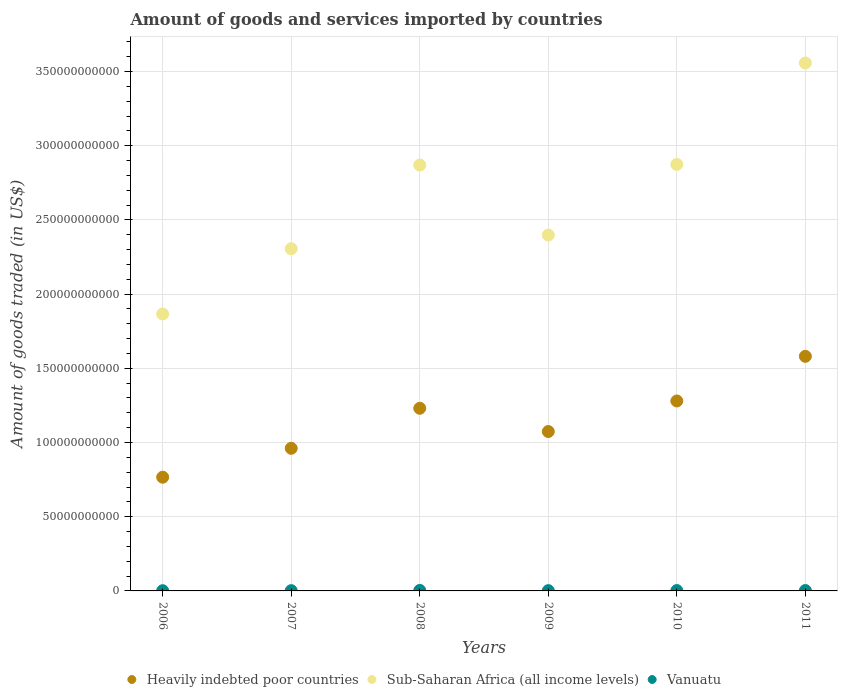Is the number of dotlines equal to the number of legend labels?
Offer a terse response. Yes. What is the total amount of goods and services imported in Heavily indebted poor countries in 2007?
Provide a short and direct response. 9.61e+1. Across all years, what is the maximum total amount of goods and services imported in Vanuatu?
Give a very brief answer. 3.18e+08. Across all years, what is the minimum total amount of goods and services imported in Vanuatu?
Your answer should be compact. 1.48e+08. In which year was the total amount of goods and services imported in Sub-Saharan Africa (all income levels) maximum?
Your answer should be compact. 2011. What is the total total amount of goods and services imported in Vanuatu in the graph?
Ensure brevity in your answer.  1.33e+09. What is the difference between the total amount of goods and services imported in Vanuatu in 2009 and that in 2011?
Give a very brief answer. -7.29e+07. What is the difference between the total amount of goods and services imported in Vanuatu in 2011 and the total amount of goods and services imported in Sub-Saharan Africa (all income levels) in 2008?
Provide a succinct answer. -2.87e+11. What is the average total amount of goods and services imported in Vanuatu per year?
Provide a short and direct response. 2.22e+08. In the year 2010, what is the difference between the total amount of goods and services imported in Vanuatu and total amount of goods and services imported in Sub-Saharan Africa (all income levels)?
Provide a short and direct response. -2.87e+11. What is the ratio of the total amount of goods and services imported in Heavily indebted poor countries in 2009 to that in 2010?
Keep it short and to the point. 0.84. What is the difference between the highest and the second highest total amount of goods and services imported in Sub-Saharan Africa (all income levels)?
Keep it short and to the point. 6.84e+1. What is the difference between the highest and the lowest total amount of goods and services imported in Vanuatu?
Provide a succinct answer. 1.70e+08. Is the sum of the total amount of goods and services imported in Vanuatu in 2006 and 2007 greater than the maximum total amount of goods and services imported in Sub-Saharan Africa (all income levels) across all years?
Offer a terse response. No. Is it the case that in every year, the sum of the total amount of goods and services imported in Vanuatu and total amount of goods and services imported in Heavily indebted poor countries  is greater than the total amount of goods and services imported in Sub-Saharan Africa (all income levels)?
Your answer should be very brief. No. How many dotlines are there?
Your response must be concise. 3. Does the graph contain grids?
Offer a very short reply. Yes. Where does the legend appear in the graph?
Provide a succinct answer. Bottom center. How many legend labels are there?
Give a very brief answer. 3. What is the title of the graph?
Give a very brief answer. Amount of goods and services imported by countries. What is the label or title of the Y-axis?
Keep it short and to the point. Amount of goods traded (in US$). What is the Amount of goods traded (in US$) of Heavily indebted poor countries in 2006?
Give a very brief answer. 7.66e+1. What is the Amount of goods traded (in US$) in Sub-Saharan Africa (all income levels) in 2006?
Your response must be concise. 1.87e+11. What is the Amount of goods traded (in US$) of Vanuatu in 2006?
Ensure brevity in your answer.  1.48e+08. What is the Amount of goods traded (in US$) of Heavily indebted poor countries in 2007?
Provide a short and direct response. 9.61e+1. What is the Amount of goods traded (in US$) of Sub-Saharan Africa (all income levels) in 2007?
Provide a succinct answer. 2.31e+11. What is the Amount of goods traded (in US$) of Vanuatu in 2007?
Your response must be concise. 1.76e+08. What is the Amount of goods traded (in US$) in Heavily indebted poor countries in 2008?
Offer a very short reply. 1.23e+11. What is the Amount of goods traded (in US$) in Sub-Saharan Africa (all income levels) in 2008?
Your answer should be very brief. 2.87e+11. What is the Amount of goods traded (in US$) in Vanuatu in 2008?
Ensure brevity in your answer.  3.18e+08. What is the Amount of goods traded (in US$) of Heavily indebted poor countries in 2009?
Ensure brevity in your answer.  1.07e+11. What is the Amount of goods traded (in US$) in Sub-Saharan Africa (all income levels) in 2009?
Provide a succinct answer. 2.40e+11. What is the Amount of goods traded (in US$) in Vanuatu in 2009?
Provide a short and direct response. 1.87e+08. What is the Amount of goods traded (in US$) of Heavily indebted poor countries in 2010?
Your answer should be very brief. 1.28e+11. What is the Amount of goods traded (in US$) in Sub-Saharan Africa (all income levels) in 2010?
Keep it short and to the point. 2.87e+11. What is the Amount of goods traded (in US$) of Vanuatu in 2010?
Provide a short and direct response. 2.44e+08. What is the Amount of goods traded (in US$) in Heavily indebted poor countries in 2011?
Give a very brief answer. 1.58e+11. What is the Amount of goods traded (in US$) of Sub-Saharan Africa (all income levels) in 2011?
Provide a succinct answer. 3.56e+11. What is the Amount of goods traded (in US$) in Vanuatu in 2011?
Keep it short and to the point. 2.60e+08. Across all years, what is the maximum Amount of goods traded (in US$) of Heavily indebted poor countries?
Make the answer very short. 1.58e+11. Across all years, what is the maximum Amount of goods traded (in US$) of Sub-Saharan Africa (all income levels)?
Make the answer very short. 3.56e+11. Across all years, what is the maximum Amount of goods traded (in US$) of Vanuatu?
Offer a very short reply. 3.18e+08. Across all years, what is the minimum Amount of goods traded (in US$) in Heavily indebted poor countries?
Your answer should be very brief. 7.66e+1. Across all years, what is the minimum Amount of goods traded (in US$) in Sub-Saharan Africa (all income levels)?
Provide a short and direct response. 1.87e+11. Across all years, what is the minimum Amount of goods traded (in US$) in Vanuatu?
Provide a short and direct response. 1.48e+08. What is the total Amount of goods traded (in US$) in Heavily indebted poor countries in the graph?
Your answer should be compact. 6.89e+11. What is the total Amount of goods traded (in US$) of Sub-Saharan Africa (all income levels) in the graph?
Your answer should be compact. 1.59e+12. What is the total Amount of goods traded (in US$) of Vanuatu in the graph?
Give a very brief answer. 1.33e+09. What is the difference between the Amount of goods traded (in US$) of Heavily indebted poor countries in 2006 and that in 2007?
Make the answer very short. -1.95e+1. What is the difference between the Amount of goods traded (in US$) of Sub-Saharan Africa (all income levels) in 2006 and that in 2007?
Offer a terse response. -4.40e+1. What is the difference between the Amount of goods traded (in US$) in Vanuatu in 2006 and that in 2007?
Provide a succinct answer. -2.89e+07. What is the difference between the Amount of goods traded (in US$) of Heavily indebted poor countries in 2006 and that in 2008?
Offer a terse response. -4.65e+1. What is the difference between the Amount of goods traded (in US$) of Sub-Saharan Africa (all income levels) in 2006 and that in 2008?
Make the answer very short. -1.00e+11. What is the difference between the Amount of goods traded (in US$) of Vanuatu in 2006 and that in 2008?
Offer a very short reply. -1.70e+08. What is the difference between the Amount of goods traded (in US$) of Heavily indebted poor countries in 2006 and that in 2009?
Your answer should be very brief. -3.08e+1. What is the difference between the Amount of goods traded (in US$) of Sub-Saharan Africa (all income levels) in 2006 and that in 2009?
Ensure brevity in your answer.  -5.32e+1. What is the difference between the Amount of goods traded (in US$) in Vanuatu in 2006 and that in 2009?
Your answer should be compact. -3.96e+07. What is the difference between the Amount of goods traded (in US$) in Heavily indebted poor countries in 2006 and that in 2010?
Give a very brief answer. -5.14e+1. What is the difference between the Amount of goods traded (in US$) of Sub-Saharan Africa (all income levels) in 2006 and that in 2010?
Offer a terse response. -1.01e+11. What is the difference between the Amount of goods traded (in US$) of Vanuatu in 2006 and that in 2010?
Provide a short and direct response. -9.62e+07. What is the difference between the Amount of goods traded (in US$) of Heavily indebted poor countries in 2006 and that in 2011?
Give a very brief answer. -8.14e+1. What is the difference between the Amount of goods traded (in US$) in Sub-Saharan Africa (all income levels) in 2006 and that in 2011?
Your answer should be very brief. -1.69e+11. What is the difference between the Amount of goods traded (in US$) of Vanuatu in 2006 and that in 2011?
Offer a very short reply. -1.12e+08. What is the difference between the Amount of goods traded (in US$) of Heavily indebted poor countries in 2007 and that in 2008?
Your answer should be compact. -2.70e+1. What is the difference between the Amount of goods traded (in US$) of Sub-Saharan Africa (all income levels) in 2007 and that in 2008?
Keep it short and to the point. -5.64e+1. What is the difference between the Amount of goods traded (in US$) in Vanuatu in 2007 and that in 2008?
Give a very brief answer. -1.41e+08. What is the difference between the Amount of goods traded (in US$) in Heavily indebted poor countries in 2007 and that in 2009?
Make the answer very short. -1.13e+1. What is the difference between the Amount of goods traded (in US$) in Sub-Saharan Africa (all income levels) in 2007 and that in 2009?
Ensure brevity in your answer.  -9.21e+09. What is the difference between the Amount of goods traded (in US$) of Vanuatu in 2007 and that in 2009?
Offer a very short reply. -1.07e+07. What is the difference between the Amount of goods traded (in US$) of Heavily indebted poor countries in 2007 and that in 2010?
Make the answer very short. -3.19e+1. What is the difference between the Amount of goods traded (in US$) of Sub-Saharan Africa (all income levels) in 2007 and that in 2010?
Your answer should be compact. -5.68e+1. What is the difference between the Amount of goods traded (in US$) in Vanuatu in 2007 and that in 2010?
Ensure brevity in your answer.  -6.73e+07. What is the difference between the Amount of goods traded (in US$) of Heavily indebted poor countries in 2007 and that in 2011?
Make the answer very short. -6.20e+1. What is the difference between the Amount of goods traded (in US$) in Sub-Saharan Africa (all income levels) in 2007 and that in 2011?
Provide a succinct answer. -1.25e+11. What is the difference between the Amount of goods traded (in US$) in Vanuatu in 2007 and that in 2011?
Provide a succinct answer. -8.36e+07. What is the difference between the Amount of goods traded (in US$) of Heavily indebted poor countries in 2008 and that in 2009?
Offer a terse response. 1.57e+1. What is the difference between the Amount of goods traded (in US$) in Sub-Saharan Africa (all income levels) in 2008 and that in 2009?
Give a very brief answer. 4.72e+1. What is the difference between the Amount of goods traded (in US$) of Vanuatu in 2008 and that in 2009?
Provide a succinct answer. 1.31e+08. What is the difference between the Amount of goods traded (in US$) of Heavily indebted poor countries in 2008 and that in 2010?
Your answer should be very brief. -4.91e+09. What is the difference between the Amount of goods traded (in US$) in Sub-Saharan Africa (all income levels) in 2008 and that in 2010?
Make the answer very short. -4.25e+08. What is the difference between the Amount of goods traded (in US$) in Vanuatu in 2008 and that in 2010?
Give a very brief answer. 7.40e+07. What is the difference between the Amount of goods traded (in US$) in Heavily indebted poor countries in 2008 and that in 2011?
Offer a terse response. -3.50e+1. What is the difference between the Amount of goods traded (in US$) in Sub-Saharan Africa (all income levels) in 2008 and that in 2011?
Your response must be concise. -6.88e+1. What is the difference between the Amount of goods traded (in US$) in Vanuatu in 2008 and that in 2011?
Your answer should be compact. 5.77e+07. What is the difference between the Amount of goods traded (in US$) in Heavily indebted poor countries in 2009 and that in 2010?
Your response must be concise. -2.06e+1. What is the difference between the Amount of goods traded (in US$) of Sub-Saharan Africa (all income levels) in 2009 and that in 2010?
Give a very brief answer. -4.76e+1. What is the difference between the Amount of goods traded (in US$) of Vanuatu in 2009 and that in 2010?
Your answer should be compact. -5.66e+07. What is the difference between the Amount of goods traded (in US$) in Heavily indebted poor countries in 2009 and that in 2011?
Your response must be concise. -5.07e+1. What is the difference between the Amount of goods traded (in US$) in Sub-Saharan Africa (all income levels) in 2009 and that in 2011?
Your response must be concise. -1.16e+11. What is the difference between the Amount of goods traded (in US$) of Vanuatu in 2009 and that in 2011?
Give a very brief answer. -7.29e+07. What is the difference between the Amount of goods traded (in US$) of Heavily indebted poor countries in 2010 and that in 2011?
Keep it short and to the point. -3.01e+1. What is the difference between the Amount of goods traded (in US$) in Sub-Saharan Africa (all income levels) in 2010 and that in 2011?
Provide a short and direct response. -6.84e+1. What is the difference between the Amount of goods traded (in US$) in Vanuatu in 2010 and that in 2011?
Offer a terse response. -1.62e+07. What is the difference between the Amount of goods traded (in US$) in Heavily indebted poor countries in 2006 and the Amount of goods traded (in US$) in Sub-Saharan Africa (all income levels) in 2007?
Keep it short and to the point. -1.54e+11. What is the difference between the Amount of goods traded (in US$) in Heavily indebted poor countries in 2006 and the Amount of goods traded (in US$) in Vanuatu in 2007?
Offer a terse response. 7.64e+1. What is the difference between the Amount of goods traded (in US$) in Sub-Saharan Africa (all income levels) in 2006 and the Amount of goods traded (in US$) in Vanuatu in 2007?
Your answer should be compact. 1.86e+11. What is the difference between the Amount of goods traded (in US$) in Heavily indebted poor countries in 2006 and the Amount of goods traded (in US$) in Sub-Saharan Africa (all income levels) in 2008?
Ensure brevity in your answer.  -2.10e+11. What is the difference between the Amount of goods traded (in US$) of Heavily indebted poor countries in 2006 and the Amount of goods traded (in US$) of Vanuatu in 2008?
Provide a succinct answer. 7.63e+1. What is the difference between the Amount of goods traded (in US$) in Sub-Saharan Africa (all income levels) in 2006 and the Amount of goods traded (in US$) in Vanuatu in 2008?
Your answer should be compact. 1.86e+11. What is the difference between the Amount of goods traded (in US$) of Heavily indebted poor countries in 2006 and the Amount of goods traded (in US$) of Sub-Saharan Africa (all income levels) in 2009?
Keep it short and to the point. -1.63e+11. What is the difference between the Amount of goods traded (in US$) in Heavily indebted poor countries in 2006 and the Amount of goods traded (in US$) in Vanuatu in 2009?
Your response must be concise. 7.64e+1. What is the difference between the Amount of goods traded (in US$) of Sub-Saharan Africa (all income levels) in 2006 and the Amount of goods traded (in US$) of Vanuatu in 2009?
Ensure brevity in your answer.  1.86e+11. What is the difference between the Amount of goods traded (in US$) in Heavily indebted poor countries in 2006 and the Amount of goods traded (in US$) in Sub-Saharan Africa (all income levels) in 2010?
Your answer should be compact. -2.11e+11. What is the difference between the Amount of goods traded (in US$) of Heavily indebted poor countries in 2006 and the Amount of goods traded (in US$) of Vanuatu in 2010?
Provide a short and direct response. 7.64e+1. What is the difference between the Amount of goods traded (in US$) of Sub-Saharan Africa (all income levels) in 2006 and the Amount of goods traded (in US$) of Vanuatu in 2010?
Offer a very short reply. 1.86e+11. What is the difference between the Amount of goods traded (in US$) in Heavily indebted poor countries in 2006 and the Amount of goods traded (in US$) in Sub-Saharan Africa (all income levels) in 2011?
Provide a succinct answer. -2.79e+11. What is the difference between the Amount of goods traded (in US$) in Heavily indebted poor countries in 2006 and the Amount of goods traded (in US$) in Vanuatu in 2011?
Make the answer very short. 7.64e+1. What is the difference between the Amount of goods traded (in US$) in Sub-Saharan Africa (all income levels) in 2006 and the Amount of goods traded (in US$) in Vanuatu in 2011?
Offer a terse response. 1.86e+11. What is the difference between the Amount of goods traded (in US$) in Heavily indebted poor countries in 2007 and the Amount of goods traded (in US$) in Sub-Saharan Africa (all income levels) in 2008?
Your answer should be very brief. -1.91e+11. What is the difference between the Amount of goods traded (in US$) of Heavily indebted poor countries in 2007 and the Amount of goods traded (in US$) of Vanuatu in 2008?
Ensure brevity in your answer.  9.58e+1. What is the difference between the Amount of goods traded (in US$) of Sub-Saharan Africa (all income levels) in 2007 and the Amount of goods traded (in US$) of Vanuatu in 2008?
Keep it short and to the point. 2.30e+11. What is the difference between the Amount of goods traded (in US$) in Heavily indebted poor countries in 2007 and the Amount of goods traded (in US$) in Sub-Saharan Africa (all income levels) in 2009?
Provide a short and direct response. -1.44e+11. What is the difference between the Amount of goods traded (in US$) in Heavily indebted poor countries in 2007 and the Amount of goods traded (in US$) in Vanuatu in 2009?
Make the answer very short. 9.59e+1. What is the difference between the Amount of goods traded (in US$) of Sub-Saharan Africa (all income levels) in 2007 and the Amount of goods traded (in US$) of Vanuatu in 2009?
Keep it short and to the point. 2.30e+11. What is the difference between the Amount of goods traded (in US$) of Heavily indebted poor countries in 2007 and the Amount of goods traded (in US$) of Sub-Saharan Africa (all income levels) in 2010?
Give a very brief answer. -1.91e+11. What is the difference between the Amount of goods traded (in US$) in Heavily indebted poor countries in 2007 and the Amount of goods traded (in US$) in Vanuatu in 2010?
Ensure brevity in your answer.  9.59e+1. What is the difference between the Amount of goods traded (in US$) in Sub-Saharan Africa (all income levels) in 2007 and the Amount of goods traded (in US$) in Vanuatu in 2010?
Your answer should be compact. 2.30e+11. What is the difference between the Amount of goods traded (in US$) of Heavily indebted poor countries in 2007 and the Amount of goods traded (in US$) of Sub-Saharan Africa (all income levels) in 2011?
Offer a terse response. -2.60e+11. What is the difference between the Amount of goods traded (in US$) of Heavily indebted poor countries in 2007 and the Amount of goods traded (in US$) of Vanuatu in 2011?
Keep it short and to the point. 9.58e+1. What is the difference between the Amount of goods traded (in US$) of Sub-Saharan Africa (all income levels) in 2007 and the Amount of goods traded (in US$) of Vanuatu in 2011?
Your answer should be very brief. 2.30e+11. What is the difference between the Amount of goods traded (in US$) in Heavily indebted poor countries in 2008 and the Amount of goods traded (in US$) in Sub-Saharan Africa (all income levels) in 2009?
Keep it short and to the point. -1.17e+11. What is the difference between the Amount of goods traded (in US$) in Heavily indebted poor countries in 2008 and the Amount of goods traded (in US$) in Vanuatu in 2009?
Provide a succinct answer. 1.23e+11. What is the difference between the Amount of goods traded (in US$) in Sub-Saharan Africa (all income levels) in 2008 and the Amount of goods traded (in US$) in Vanuatu in 2009?
Ensure brevity in your answer.  2.87e+11. What is the difference between the Amount of goods traded (in US$) of Heavily indebted poor countries in 2008 and the Amount of goods traded (in US$) of Sub-Saharan Africa (all income levels) in 2010?
Your response must be concise. -1.64e+11. What is the difference between the Amount of goods traded (in US$) in Heavily indebted poor countries in 2008 and the Amount of goods traded (in US$) in Vanuatu in 2010?
Provide a succinct answer. 1.23e+11. What is the difference between the Amount of goods traded (in US$) of Sub-Saharan Africa (all income levels) in 2008 and the Amount of goods traded (in US$) of Vanuatu in 2010?
Ensure brevity in your answer.  2.87e+11. What is the difference between the Amount of goods traded (in US$) in Heavily indebted poor countries in 2008 and the Amount of goods traded (in US$) in Sub-Saharan Africa (all income levels) in 2011?
Provide a succinct answer. -2.33e+11. What is the difference between the Amount of goods traded (in US$) in Heavily indebted poor countries in 2008 and the Amount of goods traded (in US$) in Vanuatu in 2011?
Offer a terse response. 1.23e+11. What is the difference between the Amount of goods traded (in US$) of Sub-Saharan Africa (all income levels) in 2008 and the Amount of goods traded (in US$) of Vanuatu in 2011?
Provide a succinct answer. 2.87e+11. What is the difference between the Amount of goods traded (in US$) in Heavily indebted poor countries in 2009 and the Amount of goods traded (in US$) in Sub-Saharan Africa (all income levels) in 2010?
Provide a short and direct response. -1.80e+11. What is the difference between the Amount of goods traded (in US$) in Heavily indebted poor countries in 2009 and the Amount of goods traded (in US$) in Vanuatu in 2010?
Give a very brief answer. 1.07e+11. What is the difference between the Amount of goods traded (in US$) of Sub-Saharan Africa (all income levels) in 2009 and the Amount of goods traded (in US$) of Vanuatu in 2010?
Offer a terse response. 2.40e+11. What is the difference between the Amount of goods traded (in US$) in Heavily indebted poor countries in 2009 and the Amount of goods traded (in US$) in Sub-Saharan Africa (all income levels) in 2011?
Offer a terse response. -2.48e+11. What is the difference between the Amount of goods traded (in US$) of Heavily indebted poor countries in 2009 and the Amount of goods traded (in US$) of Vanuatu in 2011?
Offer a terse response. 1.07e+11. What is the difference between the Amount of goods traded (in US$) in Sub-Saharan Africa (all income levels) in 2009 and the Amount of goods traded (in US$) in Vanuatu in 2011?
Give a very brief answer. 2.40e+11. What is the difference between the Amount of goods traded (in US$) in Heavily indebted poor countries in 2010 and the Amount of goods traded (in US$) in Sub-Saharan Africa (all income levels) in 2011?
Make the answer very short. -2.28e+11. What is the difference between the Amount of goods traded (in US$) in Heavily indebted poor countries in 2010 and the Amount of goods traded (in US$) in Vanuatu in 2011?
Offer a terse response. 1.28e+11. What is the difference between the Amount of goods traded (in US$) of Sub-Saharan Africa (all income levels) in 2010 and the Amount of goods traded (in US$) of Vanuatu in 2011?
Your answer should be compact. 2.87e+11. What is the average Amount of goods traded (in US$) in Heavily indebted poor countries per year?
Your answer should be very brief. 1.15e+11. What is the average Amount of goods traded (in US$) in Sub-Saharan Africa (all income levels) per year?
Your response must be concise. 2.65e+11. What is the average Amount of goods traded (in US$) in Vanuatu per year?
Your answer should be very brief. 2.22e+08. In the year 2006, what is the difference between the Amount of goods traded (in US$) in Heavily indebted poor countries and Amount of goods traded (in US$) in Sub-Saharan Africa (all income levels)?
Offer a terse response. -1.10e+11. In the year 2006, what is the difference between the Amount of goods traded (in US$) in Heavily indebted poor countries and Amount of goods traded (in US$) in Vanuatu?
Provide a short and direct response. 7.65e+1. In the year 2006, what is the difference between the Amount of goods traded (in US$) in Sub-Saharan Africa (all income levels) and Amount of goods traded (in US$) in Vanuatu?
Your answer should be compact. 1.86e+11. In the year 2007, what is the difference between the Amount of goods traded (in US$) in Heavily indebted poor countries and Amount of goods traded (in US$) in Sub-Saharan Africa (all income levels)?
Your response must be concise. -1.34e+11. In the year 2007, what is the difference between the Amount of goods traded (in US$) in Heavily indebted poor countries and Amount of goods traded (in US$) in Vanuatu?
Your answer should be compact. 9.59e+1. In the year 2007, what is the difference between the Amount of goods traded (in US$) of Sub-Saharan Africa (all income levels) and Amount of goods traded (in US$) of Vanuatu?
Your answer should be very brief. 2.30e+11. In the year 2008, what is the difference between the Amount of goods traded (in US$) in Heavily indebted poor countries and Amount of goods traded (in US$) in Sub-Saharan Africa (all income levels)?
Give a very brief answer. -1.64e+11. In the year 2008, what is the difference between the Amount of goods traded (in US$) in Heavily indebted poor countries and Amount of goods traded (in US$) in Vanuatu?
Ensure brevity in your answer.  1.23e+11. In the year 2008, what is the difference between the Amount of goods traded (in US$) in Sub-Saharan Africa (all income levels) and Amount of goods traded (in US$) in Vanuatu?
Offer a terse response. 2.87e+11. In the year 2009, what is the difference between the Amount of goods traded (in US$) of Heavily indebted poor countries and Amount of goods traded (in US$) of Sub-Saharan Africa (all income levels)?
Give a very brief answer. -1.32e+11. In the year 2009, what is the difference between the Amount of goods traded (in US$) of Heavily indebted poor countries and Amount of goods traded (in US$) of Vanuatu?
Your response must be concise. 1.07e+11. In the year 2009, what is the difference between the Amount of goods traded (in US$) in Sub-Saharan Africa (all income levels) and Amount of goods traded (in US$) in Vanuatu?
Your answer should be compact. 2.40e+11. In the year 2010, what is the difference between the Amount of goods traded (in US$) in Heavily indebted poor countries and Amount of goods traded (in US$) in Sub-Saharan Africa (all income levels)?
Your answer should be compact. -1.59e+11. In the year 2010, what is the difference between the Amount of goods traded (in US$) of Heavily indebted poor countries and Amount of goods traded (in US$) of Vanuatu?
Provide a short and direct response. 1.28e+11. In the year 2010, what is the difference between the Amount of goods traded (in US$) of Sub-Saharan Africa (all income levels) and Amount of goods traded (in US$) of Vanuatu?
Give a very brief answer. 2.87e+11. In the year 2011, what is the difference between the Amount of goods traded (in US$) of Heavily indebted poor countries and Amount of goods traded (in US$) of Sub-Saharan Africa (all income levels)?
Offer a very short reply. -1.98e+11. In the year 2011, what is the difference between the Amount of goods traded (in US$) of Heavily indebted poor countries and Amount of goods traded (in US$) of Vanuatu?
Your answer should be very brief. 1.58e+11. In the year 2011, what is the difference between the Amount of goods traded (in US$) of Sub-Saharan Africa (all income levels) and Amount of goods traded (in US$) of Vanuatu?
Offer a terse response. 3.55e+11. What is the ratio of the Amount of goods traded (in US$) in Heavily indebted poor countries in 2006 to that in 2007?
Give a very brief answer. 0.8. What is the ratio of the Amount of goods traded (in US$) of Sub-Saharan Africa (all income levels) in 2006 to that in 2007?
Your answer should be compact. 0.81. What is the ratio of the Amount of goods traded (in US$) of Vanuatu in 2006 to that in 2007?
Offer a very short reply. 0.84. What is the ratio of the Amount of goods traded (in US$) of Heavily indebted poor countries in 2006 to that in 2008?
Offer a terse response. 0.62. What is the ratio of the Amount of goods traded (in US$) in Sub-Saharan Africa (all income levels) in 2006 to that in 2008?
Make the answer very short. 0.65. What is the ratio of the Amount of goods traded (in US$) in Vanuatu in 2006 to that in 2008?
Offer a terse response. 0.46. What is the ratio of the Amount of goods traded (in US$) in Heavily indebted poor countries in 2006 to that in 2009?
Provide a short and direct response. 0.71. What is the ratio of the Amount of goods traded (in US$) in Sub-Saharan Africa (all income levels) in 2006 to that in 2009?
Make the answer very short. 0.78. What is the ratio of the Amount of goods traded (in US$) of Vanuatu in 2006 to that in 2009?
Your answer should be very brief. 0.79. What is the ratio of the Amount of goods traded (in US$) of Heavily indebted poor countries in 2006 to that in 2010?
Keep it short and to the point. 0.6. What is the ratio of the Amount of goods traded (in US$) of Sub-Saharan Africa (all income levels) in 2006 to that in 2010?
Keep it short and to the point. 0.65. What is the ratio of the Amount of goods traded (in US$) in Vanuatu in 2006 to that in 2010?
Your answer should be compact. 0.61. What is the ratio of the Amount of goods traded (in US$) in Heavily indebted poor countries in 2006 to that in 2011?
Provide a succinct answer. 0.48. What is the ratio of the Amount of goods traded (in US$) in Sub-Saharan Africa (all income levels) in 2006 to that in 2011?
Give a very brief answer. 0.52. What is the ratio of the Amount of goods traded (in US$) of Vanuatu in 2006 to that in 2011?
Ensure brevity in your answer.  0.57. What is the ratio of the Amount of goods traded (in US$) of Heavily indebted poor countries in 2007 to that in 2008?
Your answer should be compact. 0.78. What is the ratio of the Amount of goods traded (in US$) in Sub-Saharan Africa (all income levels) in 2007 to that in 2008?
Offer a terse response. 0.8. What is the ratio of the Amount of goods traded (in US$) of Vanuatu in 2007 to that in 2008?
Offer a very short reply. 0.56. What is the ratio of the Amount of goods traded (in US$) in Heavily indebted poor countries in 2007 to that in 2009?
Your answer should be compact. 0.89. What is the ratio of the Amount of goods traded (in US$) in Sub-Saharan Africa (all income levels) in 2007 to that in 2009?
Ensure brevity in your answer.  0.96. What is the ratio of the Amount of goods traded (in US$) of Vanuatu in 2007 to that in 2009?
Provide a short and direct response. 0.94. What is the ratio of the Amount of goods traded (in US$) of Heavily indebted poor countries in 2007 to that in 2010?
Provide a succinct answer. 0.75. What is the ratio of the Amount of goods traded (in US$) of Sub-Saharan Africa (all income levels) in 2007 to that in 2010?
Provide a short and direct response. 0.8. What is the ratio of the Amount of goods traded (in US$) of Vanuatu in 2007 to that in 2010?
Keep it short and to the point. 0.72. What is the ratio of the Amount of goods traded (in US$) of Heavily indebted poor countries in 2007 to that in 2011?
Your answer should be compact. 0.61. What is the ratio of the Amount of goods traded (in US$) of Sub-Saharan Africa (all income levels) in 2007 to that in 2011?
Offer a very short reply. 0.65. What is the ratio of the Amount of goods traded (in US$) in Vanuatu in 2007 to that in 2011?
Offer a very short reply. 0.68. What is the ratio of the Amount of goods traded (in US$) of Heavily indebted poor countries in 2008 to that in 2009?
Your answer should be compact. 1.15. What is the ratio of the Amount of goods traded (in US$) of Sub-Saharan Africa (all income levels) in 2008 to that in 2009?
Keep it short and to the point. 1.2. What is the ratio of the Amount of goods traded (in US$) in Vanuatu in 2008 to that in 2009?
Ensure brevity in your answer.  1.7. What is the ratio of the Amount of goods traded (in US$) of Heavily indebted poor countries in 2008 to that in 2010?
Ensure brevity in your answer.  0.96. What is the ratio of the Amount of goods traded (in US$) of Sub-Saharan Africa (all income levels) in 2008 to that in 2010?
Your response must be concise. 1. What is the ratio of the Amount of goods traded (in US$) of Vanuatu in 2008 to that in 2010?
Offer a terse response. 1.3. What is the ratio of the Amount of goods traded (in US$) in Heavily indebted poor countries in 2008 to that in 2011?
Provide a short and direct response. 0.78. What is the ratio of the Amount of goods traded (in US$) in Sub-Saharan Africa (all income levels) in 2008 to that in 2011?
Give a very brief answer. 0.81. What is the ratio of the Amount of goods traded (in US$) of Vanuatu in 2008 to that in 2011?
Provide a short and direct response. 1.22. What is the ratio of the Amount of goods traded (in US$) of Heavily indebted poor countries in 2009 to that in 2010?
Your response must be concise. 0.84. What is the ratio of the Amount of goods traded (in US$) in Sub-Saharan Africa (all income levels) in 2009 to that in 2010?
Provide a short and direct response. 0.83. What is the ratio of the Amount of goods traded (in US$) in Vanuatu in 2009 to that in 2010?
Provide a succinct answer. 0.77. What is the ratio of the Amount of goods traded (in US$) of Heavily indebted poor countries in 2009 to that in 2011?
Your answer should be very brief. 0.68. What is the ratio of the Amount of goods traded (in US$) in Sub-Saharan Africa (all income levels) in 2009 to that in 2011?
Your response must be concise. 0.67. What is the ratio of the Amount of goods traded (in US$) of Vanuatu in 2009 to that in 2011?
Offer a terse response. 0.72. What is the ratio of the Amount of goods traded (in US$) in Heavily indebted poor countries in 2010 to that in 2011?
Your response must be concise. 0.81. What is the ratio of the Amount of goods traded (in US$) of Sub-Saharan Africa (all income levels) in 2010 to that in 2011?
Offer a terse response. 0.81. What is the ratio of the Amount of goods traded (in US$) in Vanuatu in 2010 to that in 2011?
Keep it short and to the point. 0.94. What is the difference between the highest and the second highest Amount of goods traded (in US$) of Heavily indebted poor countries?
Your answer should be compact. 3.01e+1. What is the difference between the highest and the second highest Amount of goods traded (in US$) in Sub-Saharan Africa (all income levels)?
Offer a very short reply. 6.84e+1. What is the difference between the highest and the second highest Amount of goods traded (in US$) of Vanuatu?
Ensure brevity in your answer.  5.77e+07. What is the difference between the highest and the lowest Amount of goods traded (in US$) of Heavily indebted poor countries?
Your response must be concise. 8.14e+1. What is the difference between the highest and the lowest Amount of goods traded (in US$) in Sub-Saharan Africa (all income levels)?
Your answer should be compact. 1.69e+11. What is the difference between the highest and the lowest Amount of goods traded (in US$) of Vanuatu?
Provide a succinct answer. 1.70e+08. 